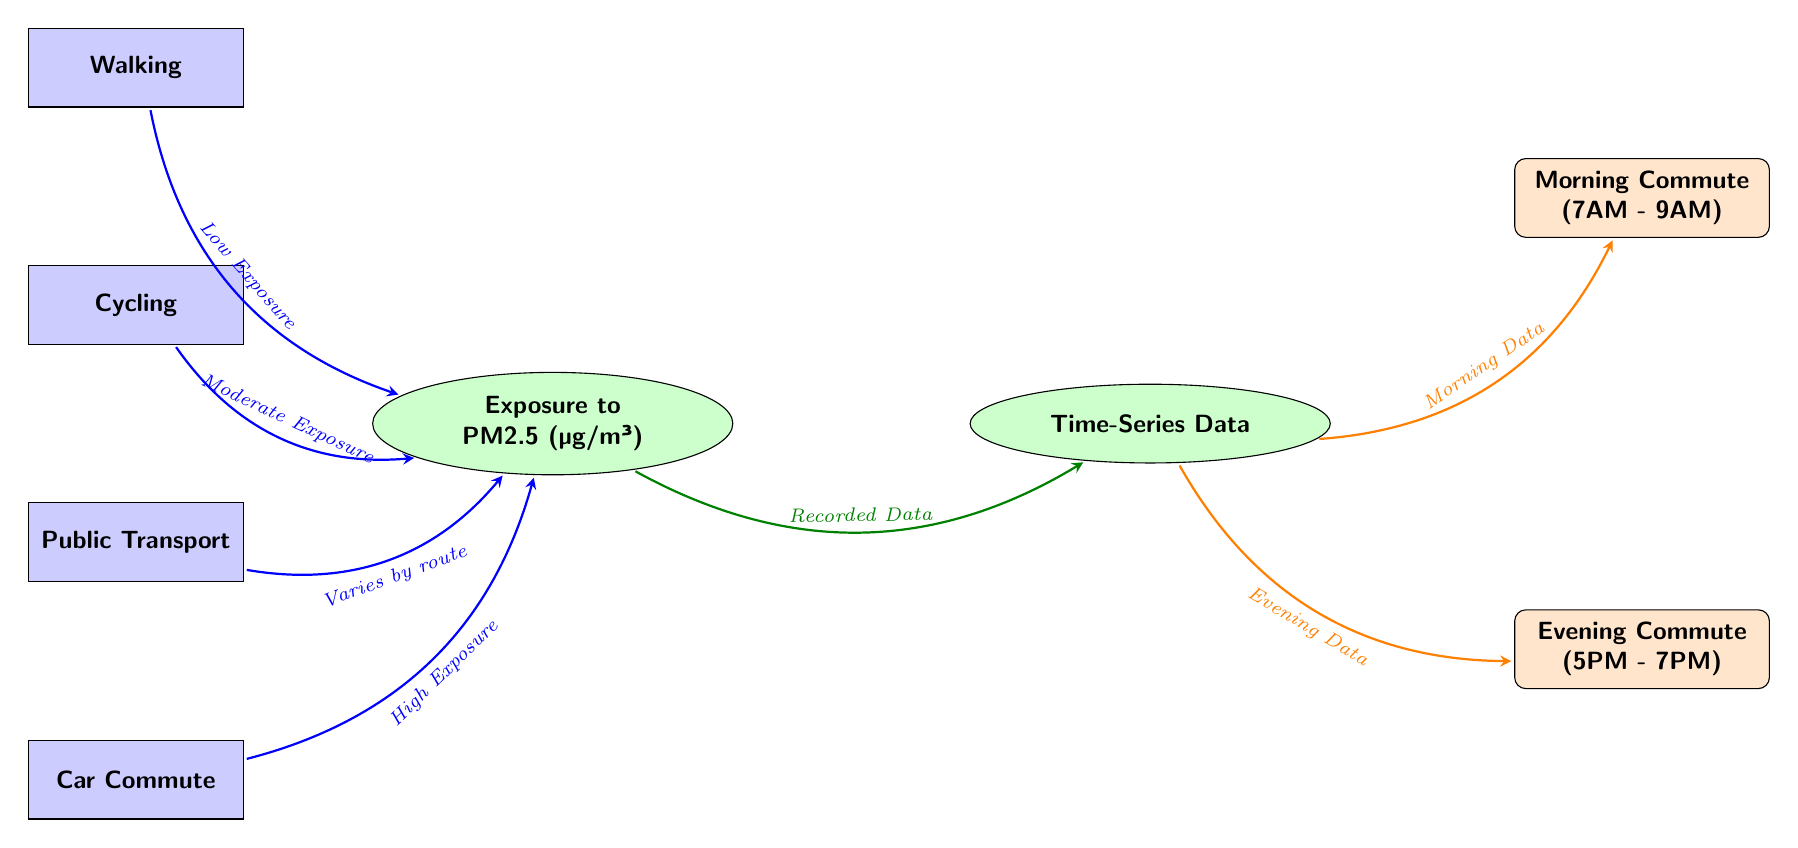What are the four modes of transportation shown in the diagram? The diagram lists four transportation modes: Walking, Cycling, Public Transport, and Car Commute. These are the main nodes representing different commuting options.
Answer: Walking, Cycling, Public Transport, Car Commute What is the exposure level associated with walking? The diagram indicates that the exposure level associated with walking is described as "Low Exposure," which is shown in an arrow connecting walking to the exposure node.
Answer: Low Exposure Which transportation mode has the highest exposure level? According to the diagram, the Car Commute has the highest exposure level, as indicated by the description "High Exposure" connecting it to the exposure node.
Answer: High Exposure What does "Varies by route" refer to in the diagram? The phrase "Varies by route" is shown in the arrow from the Public Transport node to the exposure node, indicating that exposure levels can change based on the specific route taken while using public transport.
Answer: Public Transport How many time-series data collections are indicated in the diagram? The diagram contains two time-series data collections, identified as "Morning Data" and "Evening Data," which are connected to the time-series node from the exposure node.
Answer: Two What is the time frame for the morning commute represented in the diagram? The diagram specifies the time frame for the morning commute as "7AM - 9AM," which is indicated in the time node connected to the time-series data for morning.
Answer: 7AM - 9AM What is the relationship between cycling and exposure levels? The diagram shows that cycling is associated with "Moderate Exposure," connecting cycling to the exposure level, indicating that using a bicycle results in a moderate level of pollution exposure compared to other modes.
Answer: Moderate Exposure Which two types of data are recorded in the time-series section? The two types of data recorded in the time-series section are Morning Data and Evening Data, as indicated by the arrows emanating from the timeseries node to the morning and evening time nodes.
Answer: Morning Data and Evening Data 